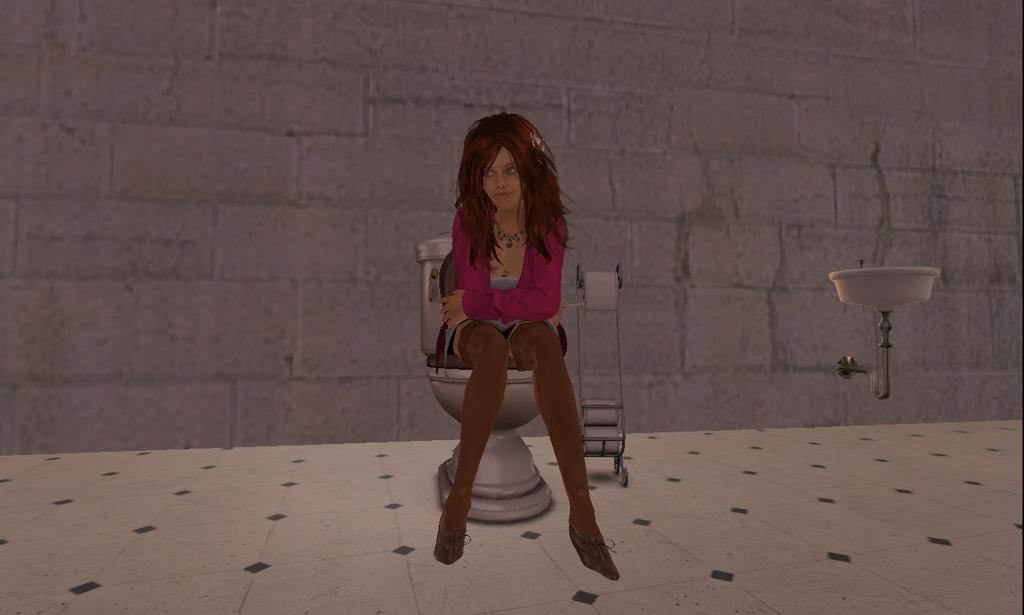What type of image is being described? The image is animated. What is the woman in the image doing? The woman is sitting on a toilet. What can be seen in the background of the image? There is a wall in the background of the image. What type of soap is the woman using in the image? There is no soap present in the image; it only shows a woman sitting on a toilet with a wall in the background. 